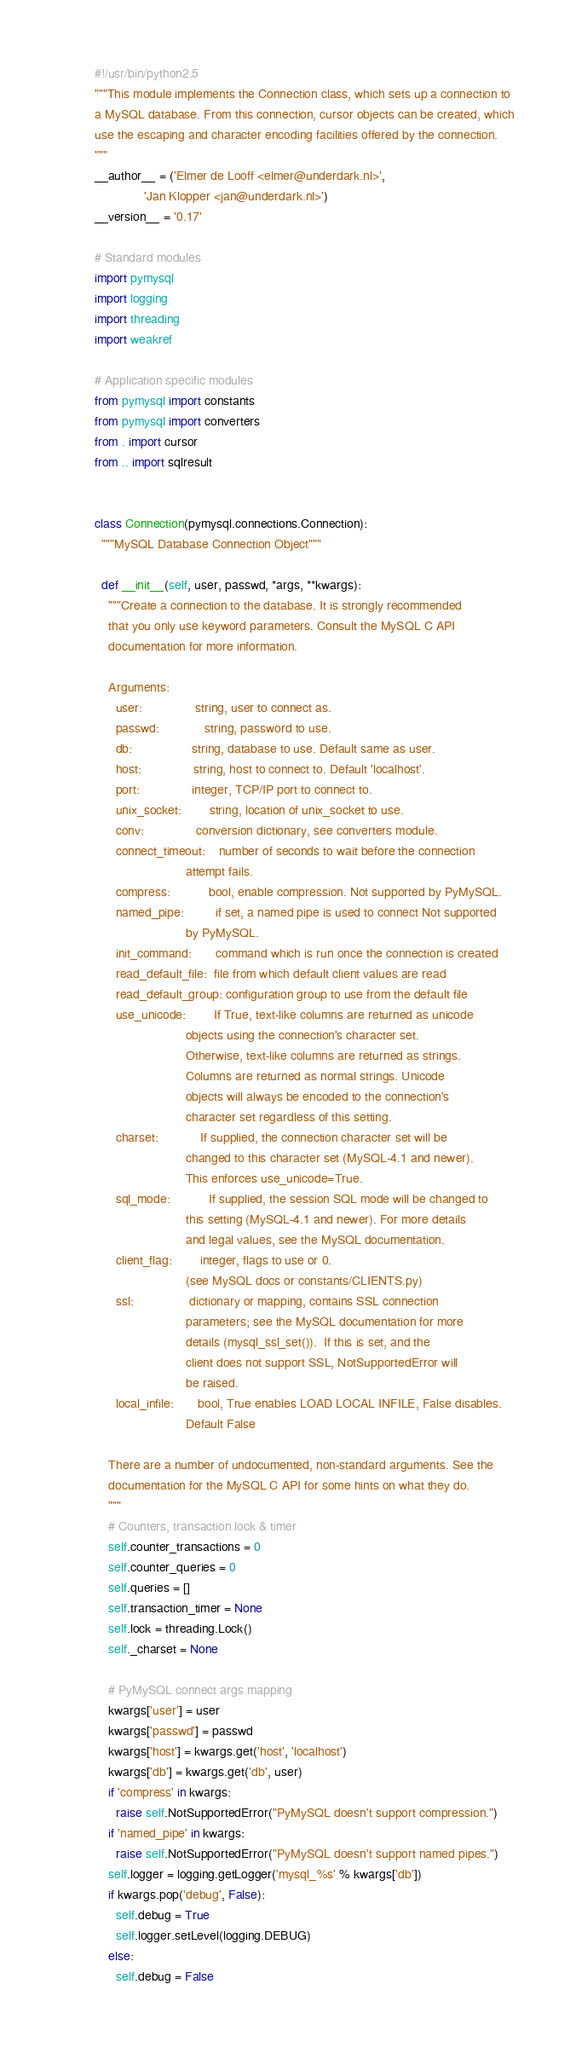Convert code to text. <code><loc_0><loc_0><loc_500><loc_500><_Python_>#!/usr/bin/python2.5
"""This module implements the Connection class, which sets up a connection to
a MySQL database. From this connection, cursor objects can be created, which
use the escaping and character encoding facilities offered by the connection.
"""
__author__ = ('Elmer de Looff <elmer@underdark.nl>',
              'Jan Klopper <jan@underdark.nl>')
__version__ = '0.17'

# Standard modules
import pymysql
import logging
import threading
import weakref

# Application specific modules
from pymysql import constants
from pymysql import converters
from . import cursor
from .. import sqlresult


class Connection(pymysql.connections.Connection):
  """MySQL Database Connection Object"""

  def __init__(self, user, passwd, *args, **kwargs):
    """Create a connection to the database. It is strongly recommended
    that you only use keyword parameters. Consult the MySQL C API
    documentation for more information.

    Arguments:
      user:               string, user to connect as.
      passwd:             string, password to use.
      db:                 string, database to use. Default same as user.
      host:               string, host to connect to. Default 'localhost'.
      port:               integer, TCP/IP port to connect to.
      unix_socket:        string, location of unix_socket to use.
      conv:               conversion dictionary, see converters module.
      connect_timeout:    number of seconds to wait before the connection
                          attempt fails.
      compress:           bool, enable compression. Not supported by PyMySQL.
      named_pipe:         if set, a named pipe is used to connect Not supported
                          by PyMySQL.
      init_command:       command which is run once the connection is created
      read_default_file:  file from which default client values are read
      read_default_group: configuration group to use from the default file
      use_unicode:        If True, text-like columns are returned as unicode
                          objects using the connection's character set.
                          Otherwise, text-like columns are returned as strings.
                          Columns are returned as normal strings. Unicode
                          objects will always be encoded to the connection's
                          character set regardless of this setting.
      charset:            If supplied, the connection character set will be
                          changed to this character set (MySQL-4.1 and newer).
                          This enforces use_unicode=True.
      sql_mode:           If supplied, the session SQL mode will be changed to
                          this setting (MySQL-4.1 and newer). For more details
                          and legal values, see the MySQL documentation.
      client_flag:        integer, flags to use or 0.
                          (see MySQL docs or constants/CLIENTS.py)
      ssl:                dictionary or mapping, contains SSL connection
                          parameters; see the MySQL documentation for more
                          details (mysql_ssl_set()).  If this is set, and the
                          client does not support SSL, NotSupportedError will
                          be raised.
      local_infile:       bool, True enables LOAD LOCAL INFILE, False disables.
                          Default False

    There are a number of undocumented, non-standard arguments. See the
    documentation for the MySQL C API for some hints on what they do.
    """
    # Counters, transaction lock & timer
    self.counter_transactions = 0
    self.counter_queries = 0
    self.queries = []
    self.transaction_timer = None
    self.lock = threading.Lock()
    self._charset = None

    # PyMySQL connect args mapping
    kwargs['user'] = user
    kwargs['passwd'] = passwd
    kwargs['host'] = kwargs.get('host', 'localhost')
    kwargs['db'] = kwargs.get('db', user)
    if 'compress' in kwargs:
      raise self.NotSupportedError("PyMySQL doesn't support compression.")
    if 'named_pipe' in kwargs:
      raise self.NotSupportedError("PyMySQL doesn't support named pipes.")
    self.logger = logging.getLogger('mysql_%s' % kwargs['db'])
    if kwargs.pop('debug', False):
      self.debug = True
      self.logger.setLevel(logging.DEBUG)
    else:
      self.debug = False</code> 